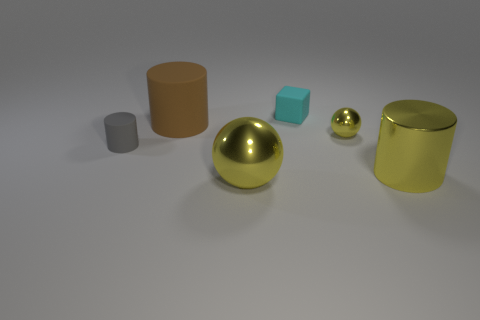Add 3 small yellow metallic cubes. How many objects exist? 9 Subtract all cubes. How many objects are left? 5 Subtract 0 blue cylinders. How many objects are left? 6 Subtract all yellow objects. Subtract all yellow metallic objects. How many objects are left? 0 Add 1 metallic spheres. How many metallic spheres are left? 3 Add 2 large red blocks. How many large red blocks exist? 2 